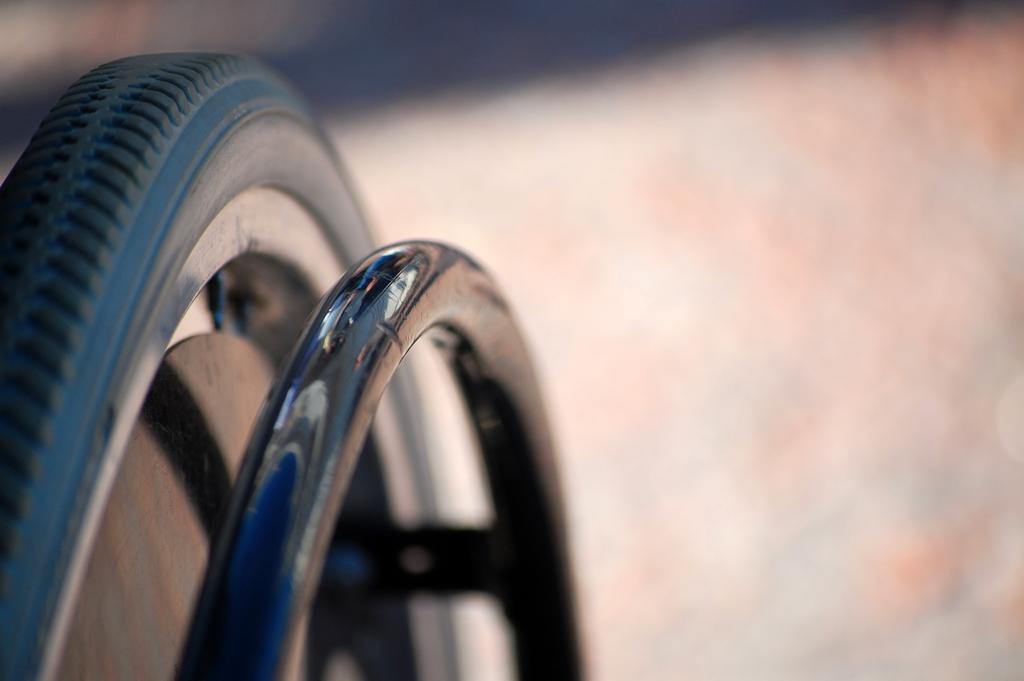Where was the image taken? The image was taken outdoors. Can you describe the background of the image? The background of the image is a little blurred. What objects can be seen in the image? There is a wheel and a tire in the image. What type of egg is being held by the hands in the image? There are no hands or eggs present in the image. What letters can be seen on the tire in the image? The tire in the image does not have any visible letters. 